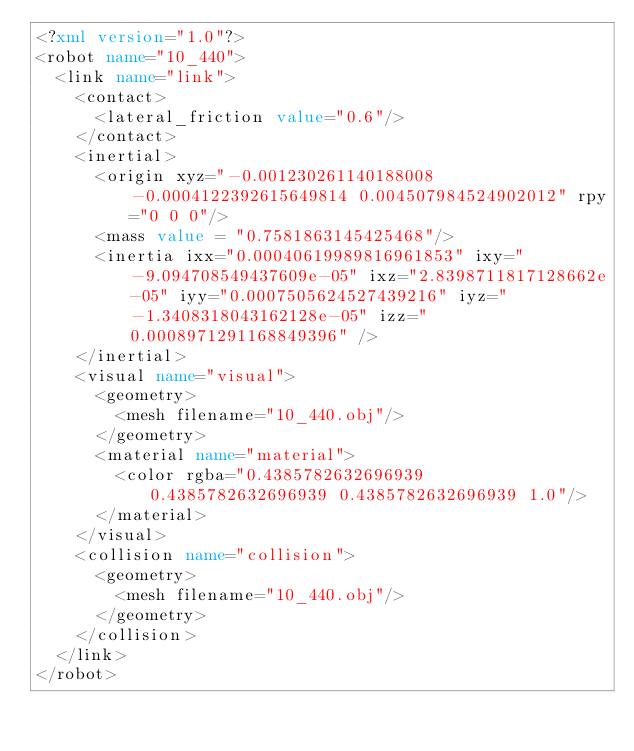Convert code to text. <code><loc_0><loc_0><loc_500><loc_500><_XML_><?xml version="1.0"?>
<robot name="10_440">
  <link name="link">
    <contact>
      <lateral_friction value="0.6"/>
    </contact>
    <inertial>
      <origin xyz="-0.001230261140188008 -0.0004122392615649814 0.004507984524902012" rpy="0 0 0"/>
      <mass value = "0.7581863145425468"/>
      <inertia ixx="0.00040619989816961853" ixy="-9.094708549437609e-05" ixz="2.8398711817128662e-05" iyy="0.0007505624527439216" iyz="-1.3408318043162128e-05" izz="0.0008971291168849396" />
    </inertial>
    <visual name="visual">
      <geometry>
        <mesh filename="10_440.obj"/>
      </geometry>
      <material name="material">
        <color rgba="0.4385782632696939 0.4385782632696939 0.4385782632696939 1.0"/>
      </material>
    </visual>
    <collision name="collision">
      <geometry>
        <mesh filename="10_440.obj"/>
      </geometry>
    </collision>
  </link>
</robot>
</code> 